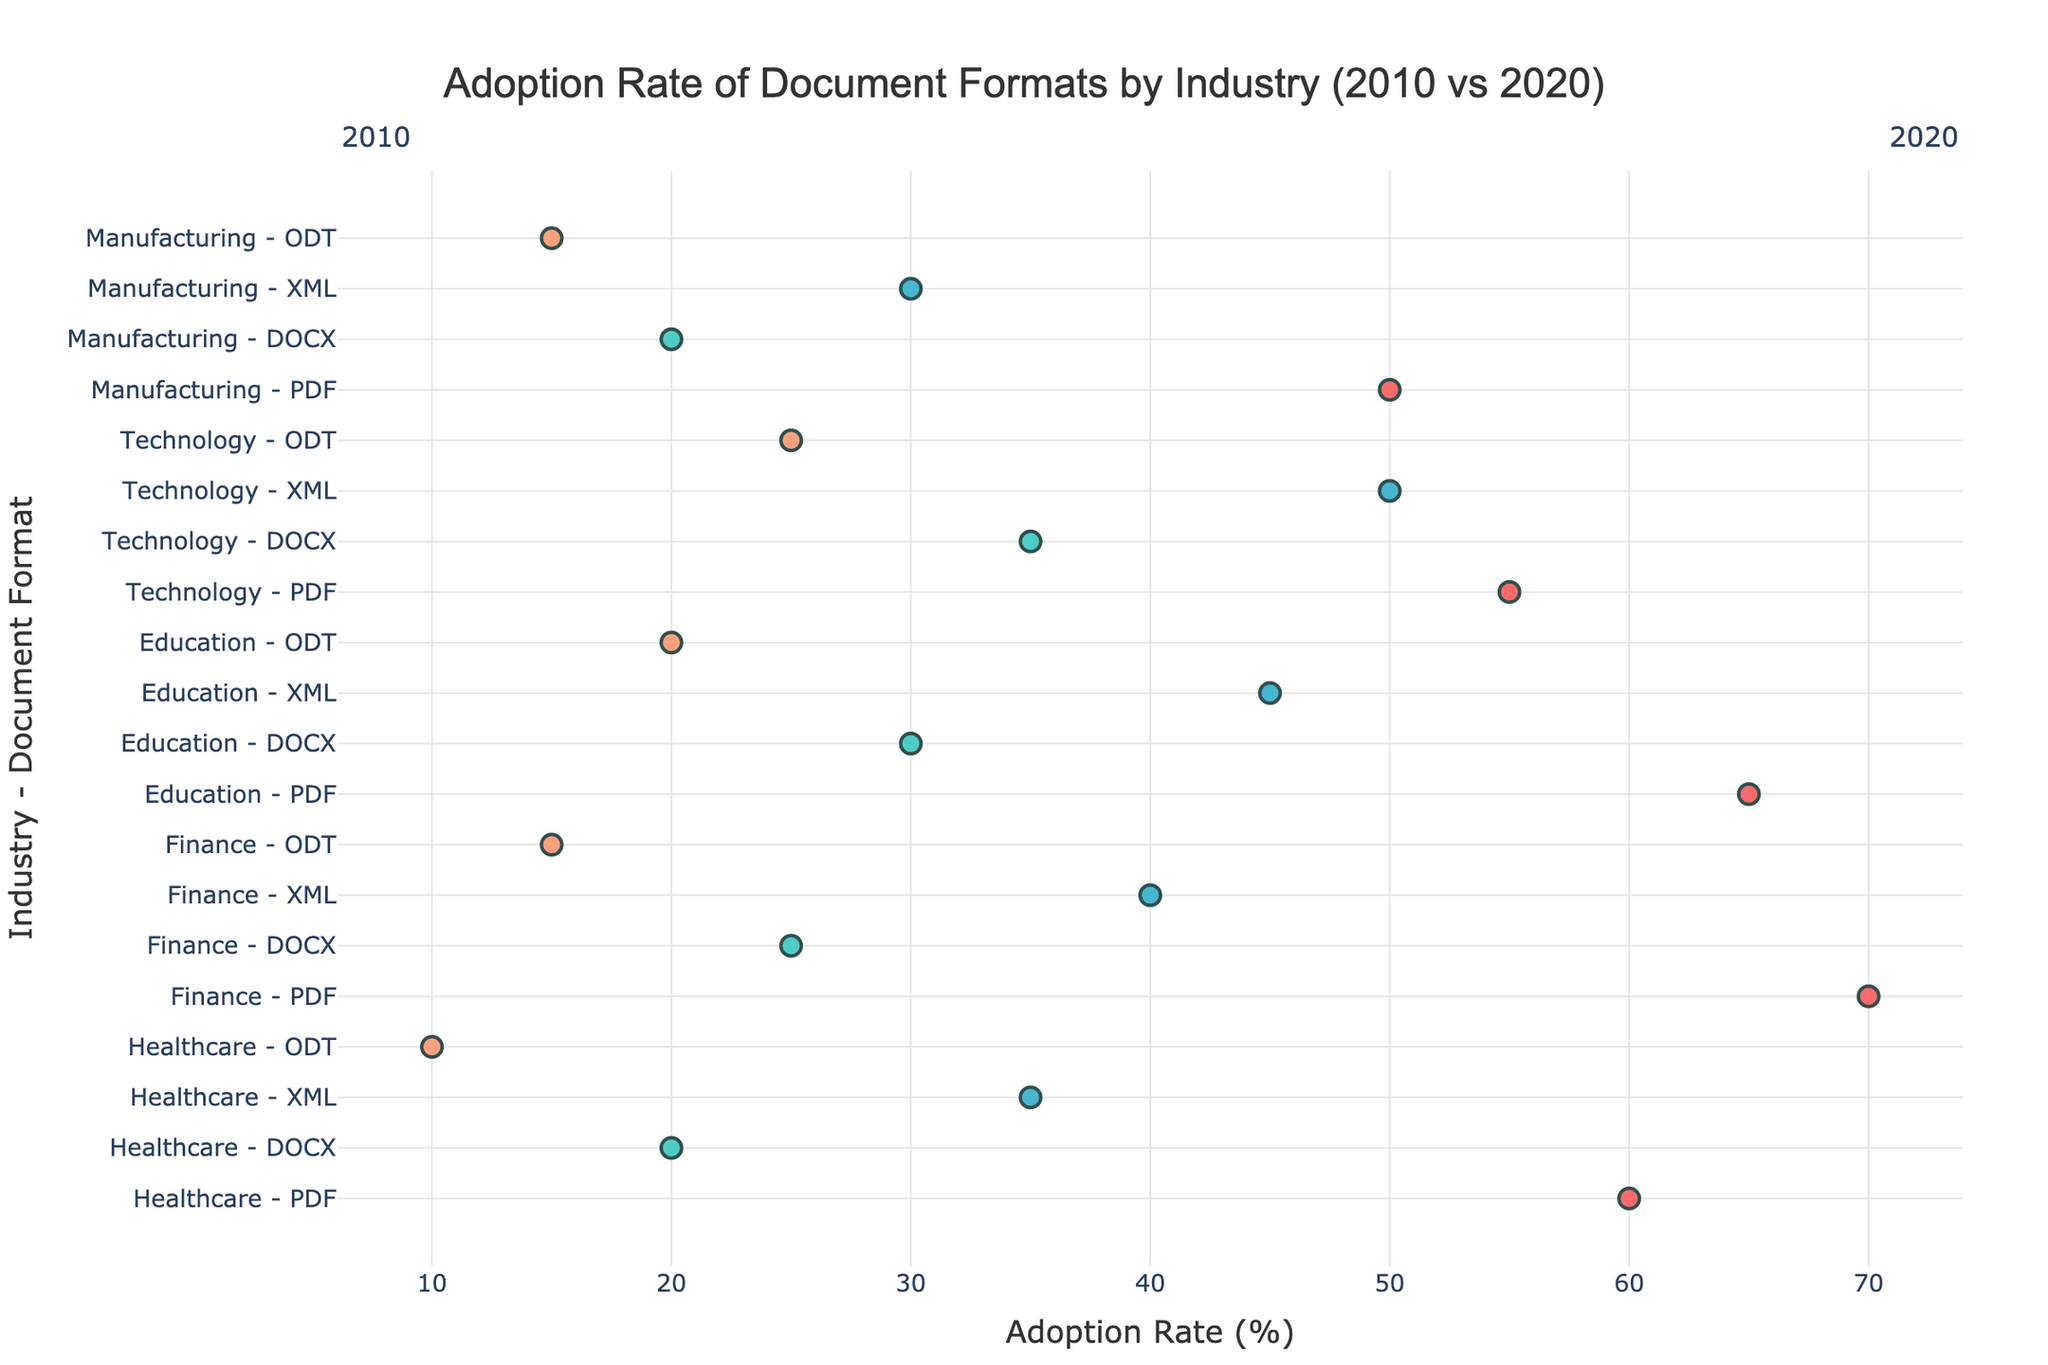What is the title of the plot? The title is typically placed at the top of the figure. Reading the text there gives us the name of the plot.
Answer: "Adoption Rate of Document Formats by Industry (2010 vs 2020)" What is the adoption rate of PDF in the Healthcare industry in 2020? Look for the point corresponding to Healthcare - PDF on the y-axis and follow the line to 2020 on the x-axis.
Answer: 85% Which industry had the highest increase in adoption rate for XML from 2010 to 2020? Identify the XML lines for each industry and measure the increase from the 2010 to 2020 points, determining which has the greatest difference.
Answer: Technology What is the average adoption rate of DOCX in all industries in 2010? Sum the adoption rates of DOCX for all industries in 2010 and divide by the number of industries (5). (20+25+30+35+20)/5
Answer: 26 How does the adoption rate of ODT in Education compare between 2010 and 2020? Identify the points for Education - ODT on the y-axis, and compare the x-axis values for 2010 and 2020.
Answer: Increased from 20% to 35% What is the difference in adoption rate of XML between Finance and Manufacturing in 2020? Compare the x-axis values for XML in Finance and Manufacturing in 2020 and calculate the difference. (70-50)
Answer: 20% Which document format had the least increase in adoption rate in the Manufacturing industry from 2010 to 2020? Identify each document format's line for Manufacturing, then measure the increase between 2010 and 2020 by subtracting the start value from the end value.
Answer: DOCX In which industry is the 2020 adoption rate of PDF higher than 80%? Locate the 2020 points for PDF on the x-axis and identify which industry's adoption rate surpasses 80%.
Answer: Healthcare, Finance, Education What is the total increase in adoption rate for PDF across all industries from 2010 to 2020? Sum the increases in adoption rates of PDF for each industry from 2010 to 2020. (85-60) + (90-70) + (80-65) + (75-55) + (70-50)
Answer: 70% Which document format in the Technology industry had the highest adoption rate in 2010? Among the plotting points in the Technology industry for 2010, identify which document format has the highest value.
Answer: XML 